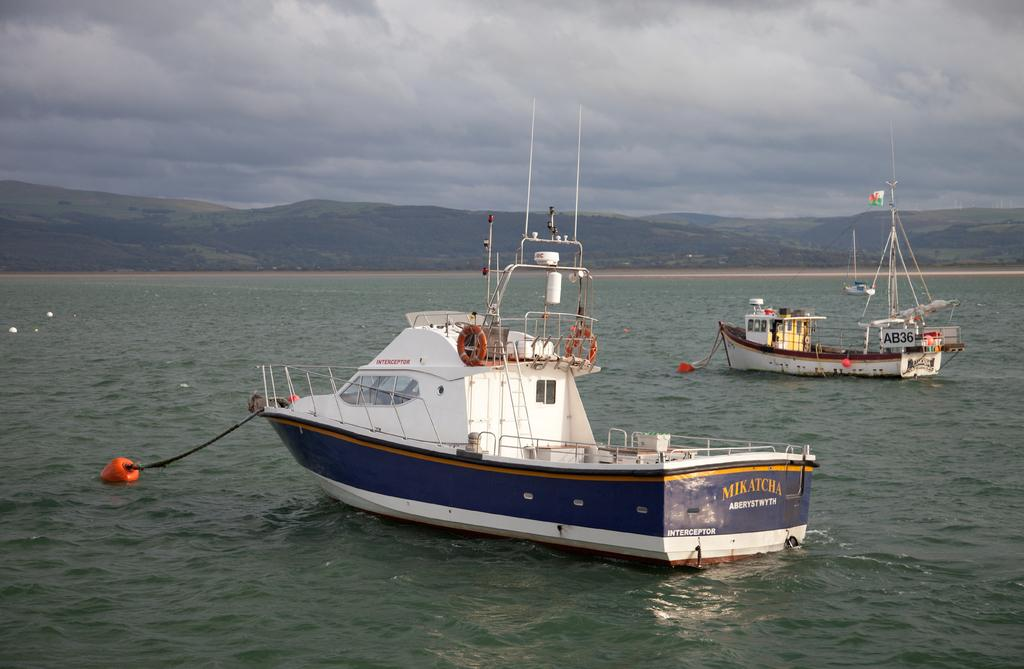Where is the image taken? The image is taken in an ocean. What can be seen in the water in the image? There are two boats in the image. What is visible in the background of the image? There is a mountain in the background of the image. What is visible at the top of the image? Clouds are visible at the top of the image. What type of list can be seen on the stage in the image? There is no stage or list present in the image; it is taken in an ocean with two boats and a mountain in the background. 